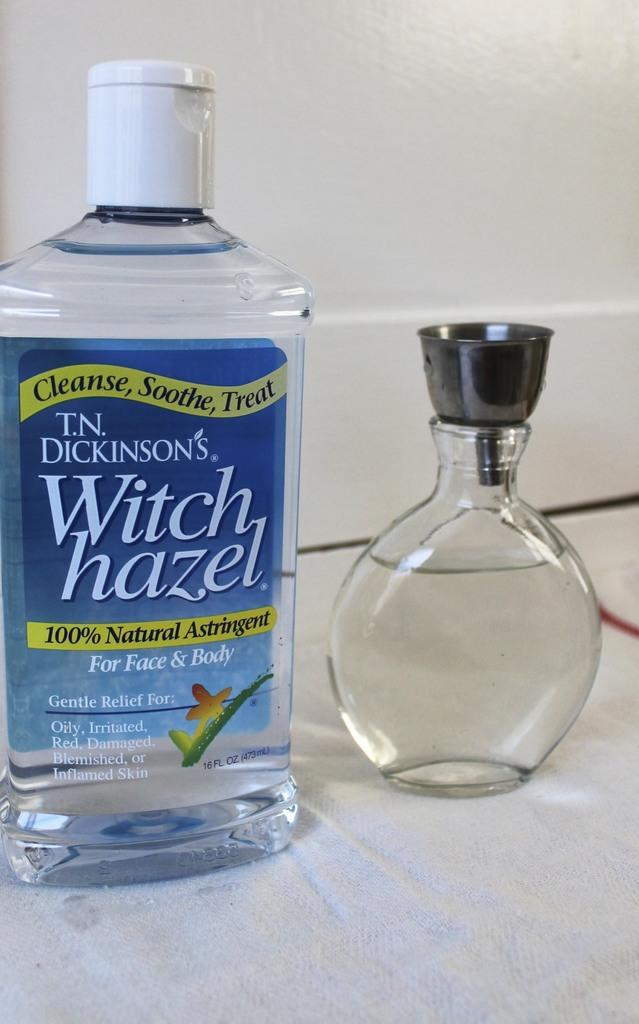What is the product designed to be used on?
Offer a terse response. Face and body. What is the band on the bottle?
Your answer should be compact. T.n. dickinson's. 